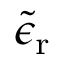Convert formula to latex. <formula><loc_0><loc_0><loc_500><loc_500>\tilde { \epsilon } _ { r }</formula> 